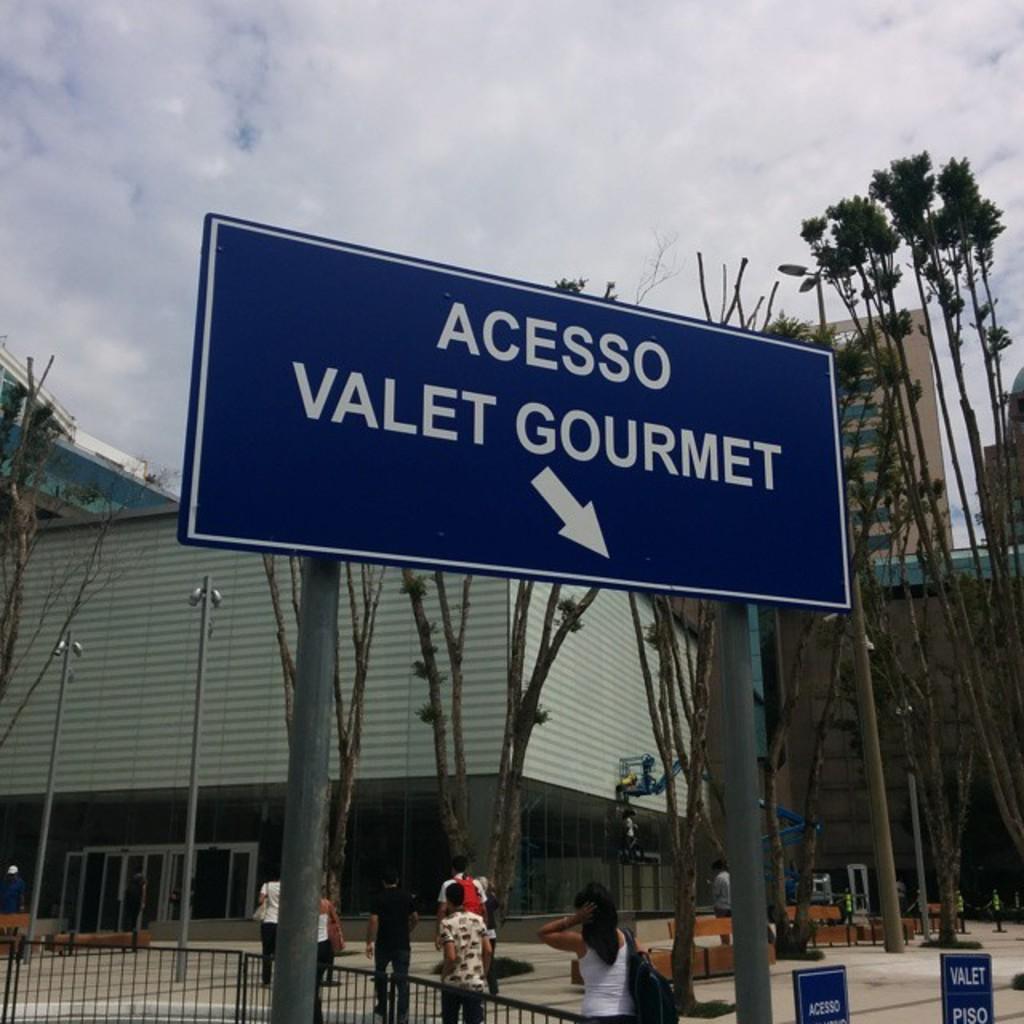What is to the right?
Provide a short and direct response. Acesso valet gourmet. 